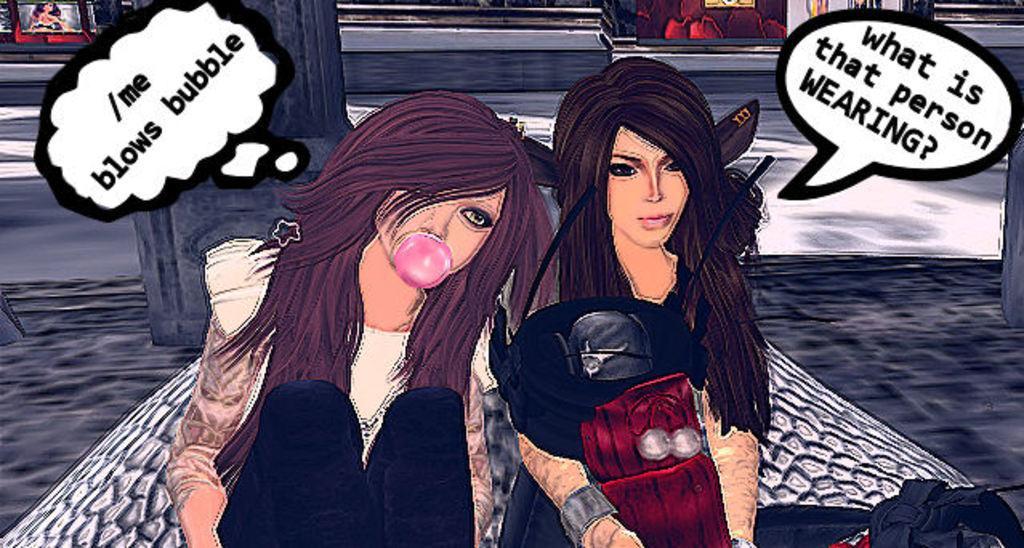Please provide a concise description of this image. In this image I can see two cartoon persons. I can also see a frame attached to the wall and the person at right wearing black dress and the person at left wearing cream color dress. 